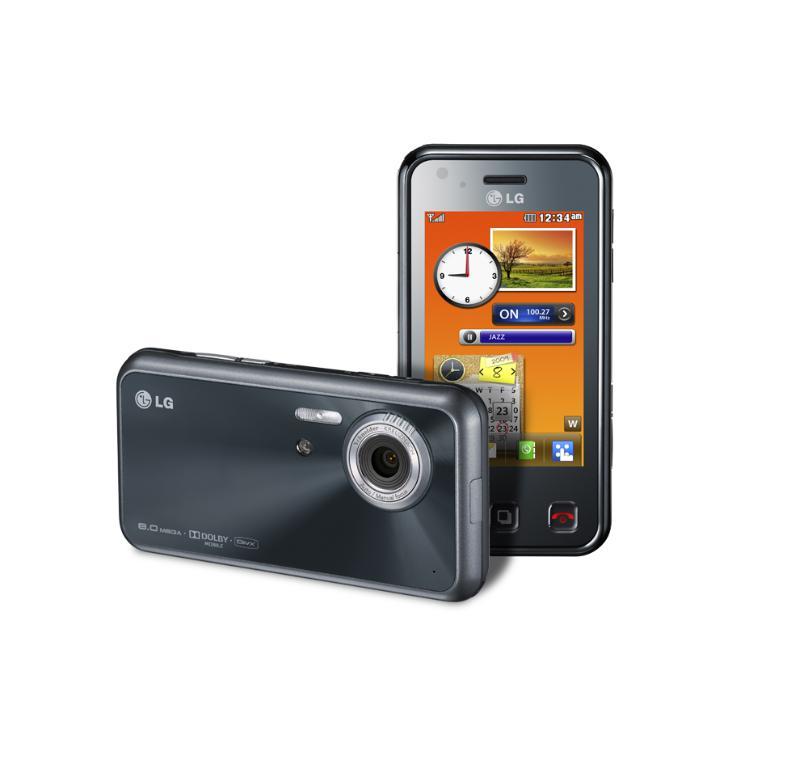What time is it on the phone?
Offer a very short reply. 12:34. 